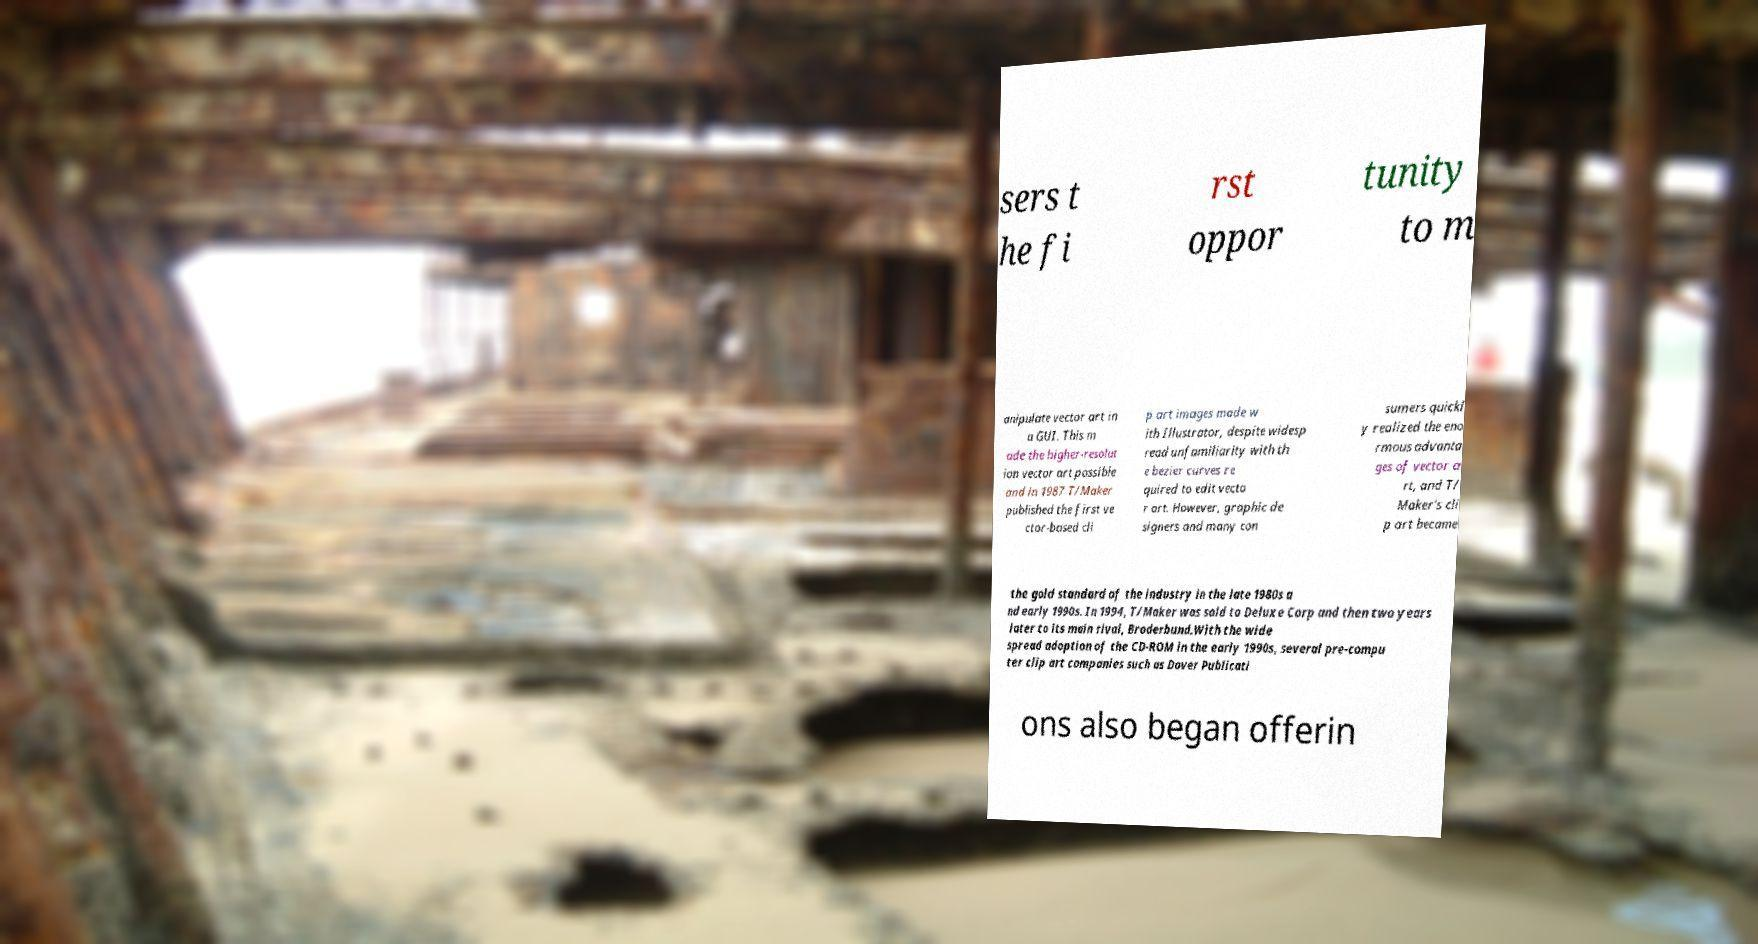What messages or text are displayed in this image? I need them in a readable, typed format. sers t he fi rst oppor tunity to m anipulate vector art in a GUI. This m ade the higher-resolut ion vector art possible and in 1987 T/Maker published the first ve ctor-based cli p art images made w ith Illustrator, despite widesp read unfamiliarity with th e bezier curves re quired to edit vecto r art. However, graphic de signers and many con sumers quickl y realized the eno rmous advanta ges of vector a rt, and T/ Maker's cli p art became the gold standard of the industry in the late 1980s a nd early 1990s. In 1994, T/Maker was sold to Deluxe Corp and then two years later to its main rival, Broderbund.With the wide spread adoption of the CD-ROM in the early 1990s, several pre-compu ter clip art companies such as Dover Publicati ons also began offerin 